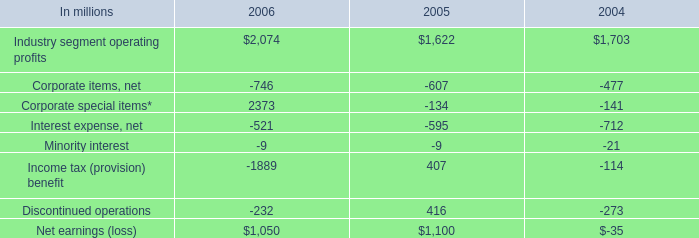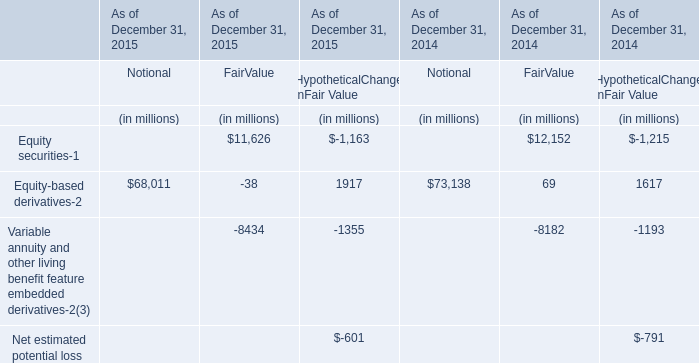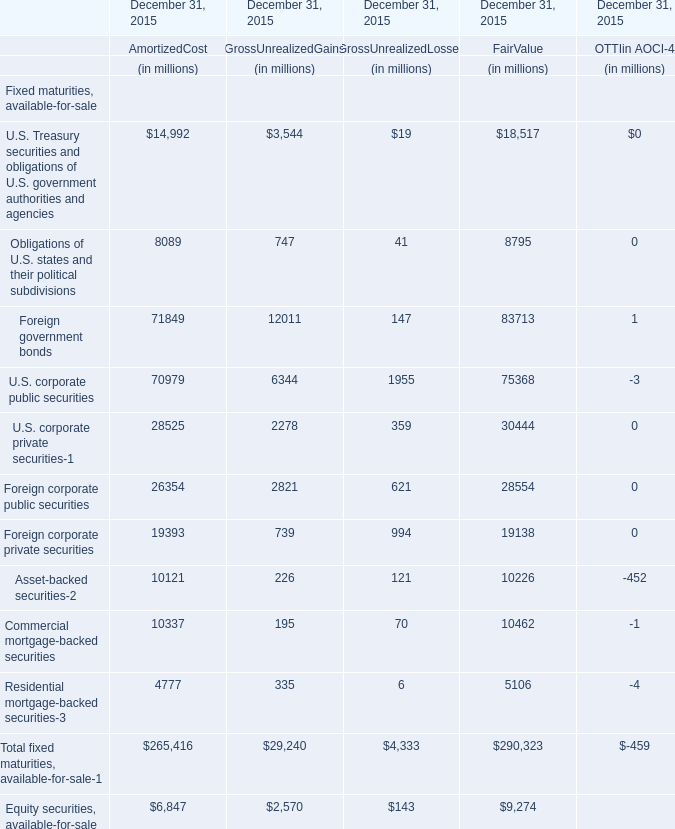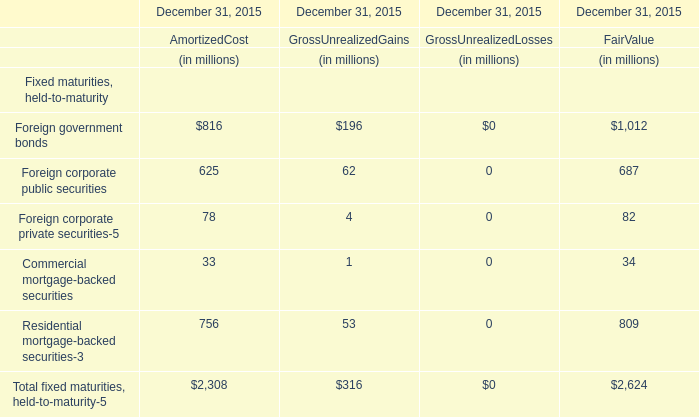Which fair value occupies the greatest proportion in total amount (in 2015)? 
Computations: (1012 / 2624)
Answer: 0.38567. 